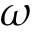Convert formula to latex. <formula><loc_0><loc_0><loc_500><loc_500>\omega</formula> 